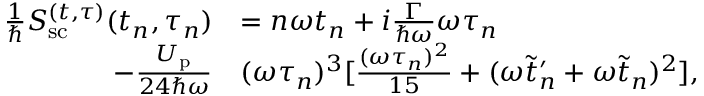Convert formula to latex. <formula><loc_0><loc_0><loc_500><loc_500>\begin{array} { r l } { \frac { 1 } { } S _ { s c } ^ { ( t , \tau ) } ( t _ { n } , \tau _ { n } ) } & { = n \omega t _ { n } + i \frac { \Gamma } { \hbar { \omega } } \omega \tau _ { n } } \\ { - \frac { U _ { p } } { 2 4 \hbar { \omega } } } & { ( \omega \tau _ { n } ) ^ { 3 } [ \frac { ( \omega \tau _ { n } ) ^ { 2 } } { 1 5 } + ( \omega \tilde { t } _ { n } ^ { \prime } + \omega \tilde { t } _ { n } ) ^ { 2 } ] , } \end{array}</formula> 